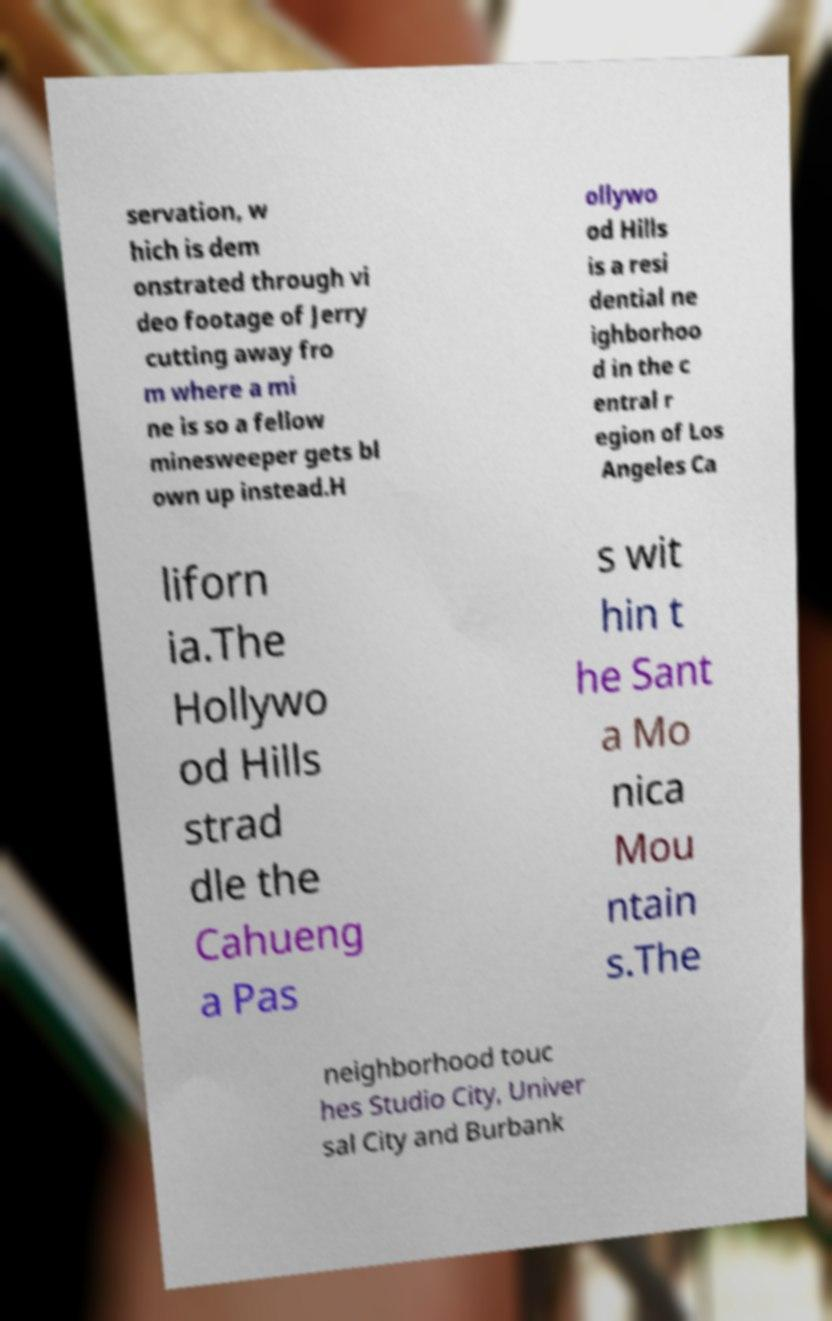I need the written content from this picture converted into text. Can you do that? servation, w hich is dem onstrated through vi deo footage of Jerry cutting away fro m where a mi ne is so a fellow minesweeper gets bl own up instead.H ollywo od Hills is a resi dential ne ighborhoo d in the c entral r egion of Los Angeles Ca liforn ia.The Hollywo od Hills strad dle the Cahueng a Pas s wit hin t he Sant a Mo nica Mou ntain s.The neighborhood touc hes Studio City, Univer sal City and Burbank 